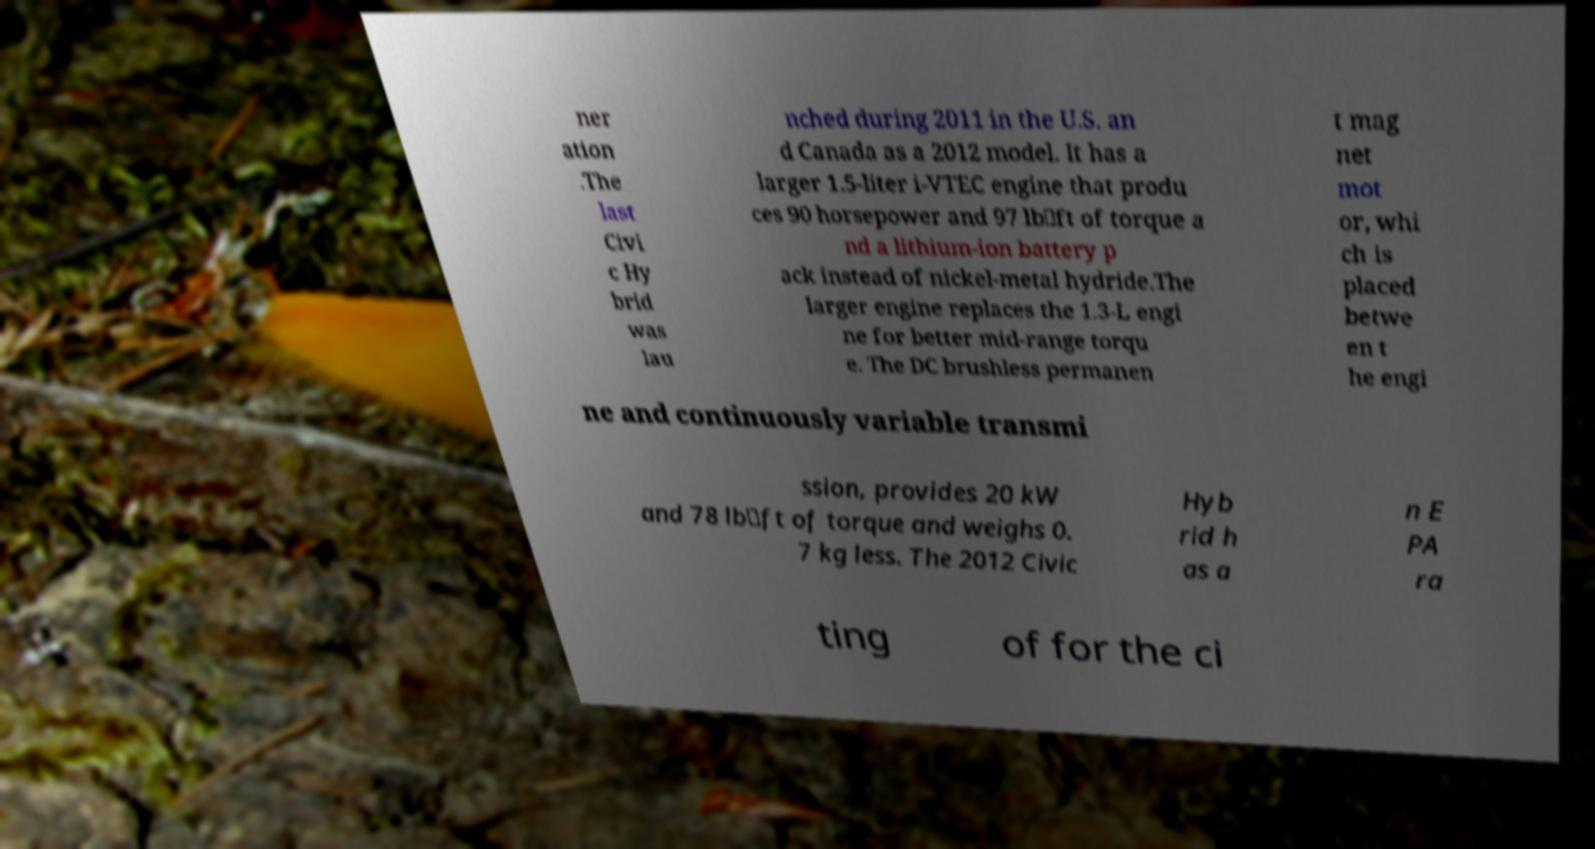Could you assist in decoding the text presented in this image and type it out clearly? ner ation .The last Civi c Hy brid was lau nched during 2011 in the U.S. an d Canada as a 2012 model. It has a larger 1.5-liter i-VTEC engine that produ ces 90 horsepower and 97 lb⋅ft of torque a nd a lithium-ion battery p ack instead of nickel-metal hydride.The larger engine replaces the 1.3-L engi ne for better mid-range torqu e. The DC brushless permanen t mag net mot or, whi ch is placed betwe en t he engi ne and continuously variable transmi ssion, provides 20 kW and 78 lb⋅ft of torque and weighs 0. 7 kg less. The 2012 Civic Hyb rid h as a n E PA ra ting of for the ci 